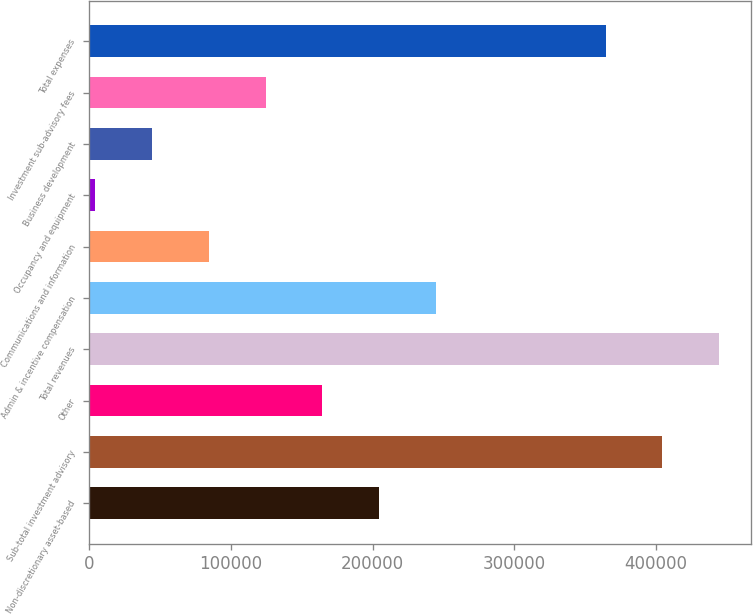Convert chart to OTSL. <chart><loc_0><loc_0><loc_500><loc_500><bar_chart><fcel>Non-discretionary asset-based<fcel>Sub-total investment advisory<fcel>Other<fcel>Total revenues<fcel>Admin & incentive compensation<fcel>Communications and information<fcel>Occupancy and equipment<fcel>Business development<fcel>Investment sub-advisory fees<fcel>Total expenses<nl><fcel>204422<fcel>404421<fcel>164422<fcel>444421<fcel>244422<fcel>84422.6<fcel>4423<fcel>44422.8<fcel>124422<fcel>364421<nl></chart> 